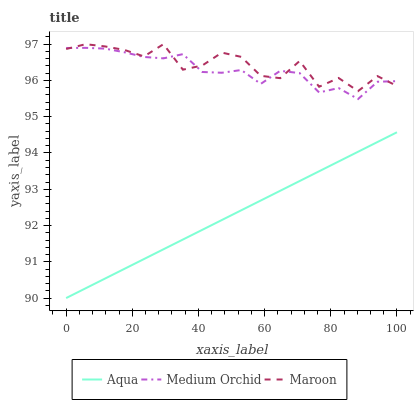Does Aqua have the minimum area under the curve?
Answer yes or no. Yes. Does Maroon have the maximum area under the curve?
Answer yes or no. Yes. Does Maroon have the minimum area under the curve?
Answer yes or no. No. Does Aqua have the maximum area under the curve?
Answer yes or no. No. Is Aqua the smoothest?
Answer yes or no. Yes. Is Maroon the roughest?
Answer yes or no. Yes. Is Maroon the smoothest?
Answer yes or no. No. Is Aqua the roughest?
Answer yes or no. No. Does Aqua have the lowest value?
Answer yes or no. Yes. Does Maroon have the lowest value?
Answer yes or no. No. Does Maroon have the highest value?
Answer yes or no. Yes. Does Aqua have the highest value?
Answer yes or no. No. Is Aqua less than Maroon?
Answer yes or no. Yes. Is Maroon greater than Aqua?
Answer yes or no. Yes. Does Maroon intersect Medium Orchid?
Answer yes or no. Yes. Is Maroon less than Medium Orchid?
Answer yes or no. No. Is Maroon greater than Medium Orchid?
Answer yes or no. No. Does Aqua intersect Maroon?
Answer yes or no. No. 